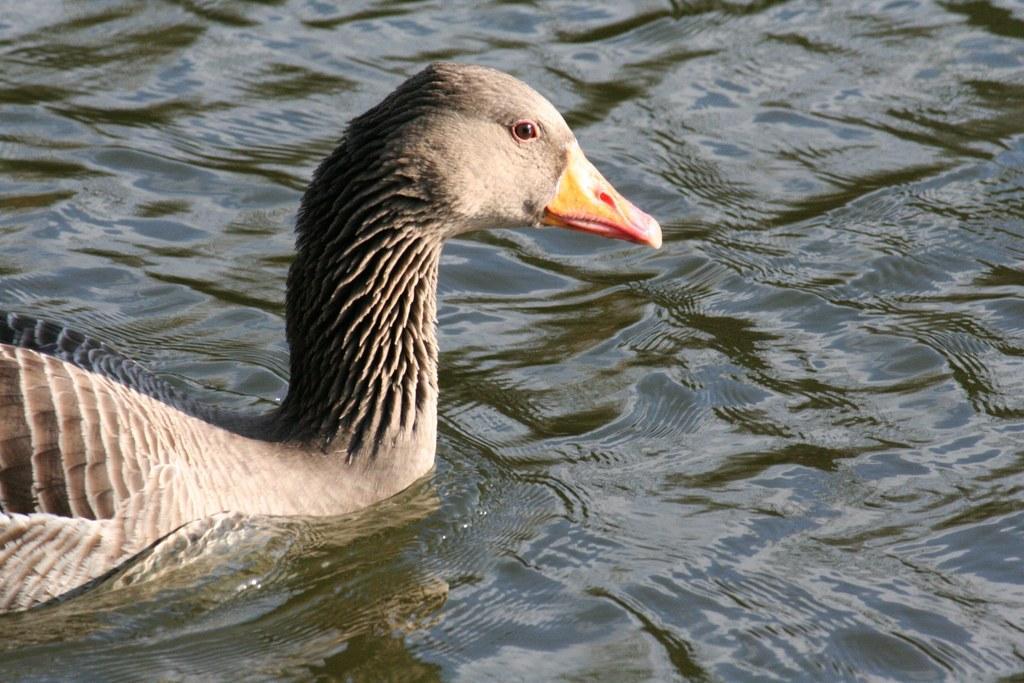Could you give a brief overview of what you see in this image? In this image there is a duck in the water. 